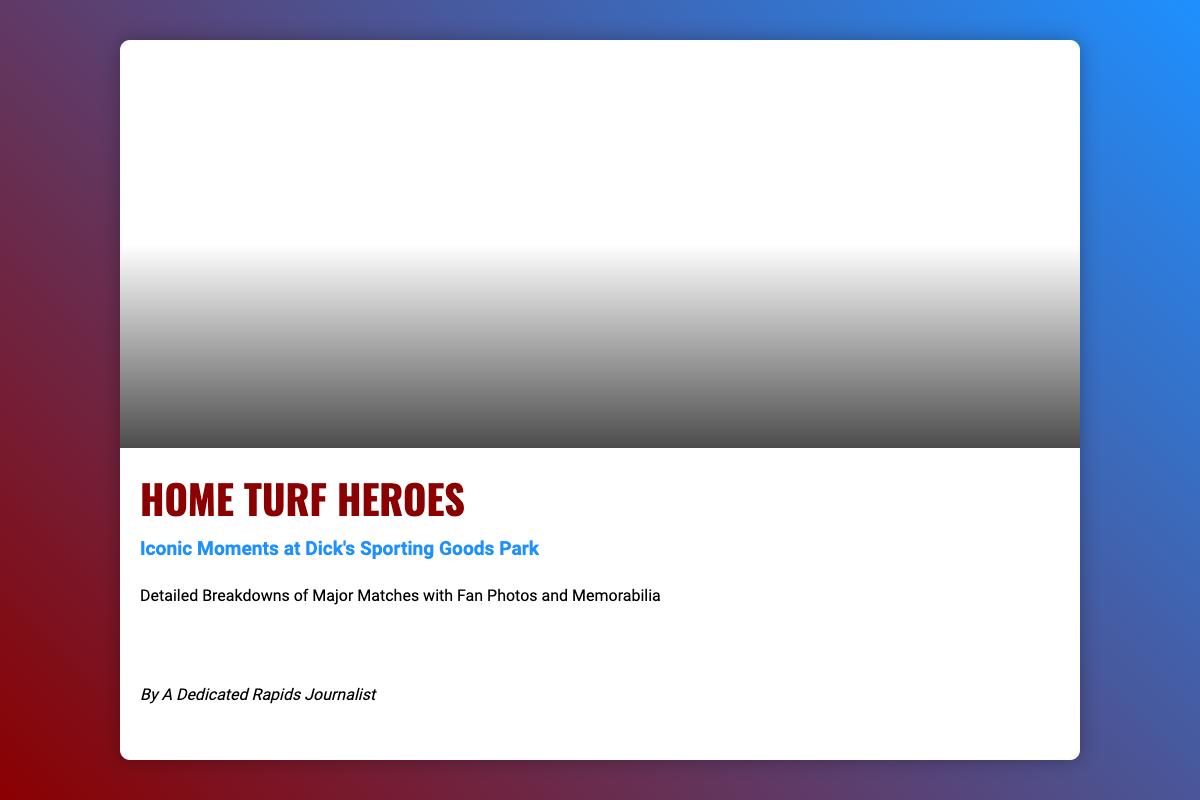What is the title of the book? The title is prominently displayed in large font at the top of the cover, which is "Home Turf Heroes".
Answer: Home Turf Heroes What is the subtitle of the book? The subtitle is located beneath the main title and provides additional context, it reads "Iconic Moments at Dick's Sporting Goods Park".
Answer: Iconic Moments at Dick's Sporting Goods Park Who is the author of the book? The author's name is included in italics at the bottom of the cover, stating "By A Dedicated Rapids Journalist".
Answer: A Dedicated Rapids Journalist What type of content does the book include? The description on the cover details the content, stating "Detailed Breakdowns of Major Matches with Fan Photos and Memorabilia".
Answer: Detailed Breakdowns of Major Matches with Fan Photos and Memorabilia What colors are used in the cover design? The background of the cover features a linear gradient of two colors, #8B0000 and #1E90FF.
Answer: #8B0000 and #1E90FF What visual elements are highlighted in the cover? The icons at the bottom represent soccer, photography, and trophies, indicating themes in the book.
Answer: Soccer, photography, trophies How is the cover's layout structured? The layout is divided into an image section at the top and a text section at the bottom, creating a balanced design.
Answer: Image section and text section What is the dominant image theme on the cover? The cover features a dynamic stadium image that captures vibrant crowd scenes from matches.
Answer: Dynamic stadium image with vibrant crowd scenes What is the primary font used for the title? The title uses the 'Oswald' font, which is specific to the visual identity of the book.
Answer: Oswald 